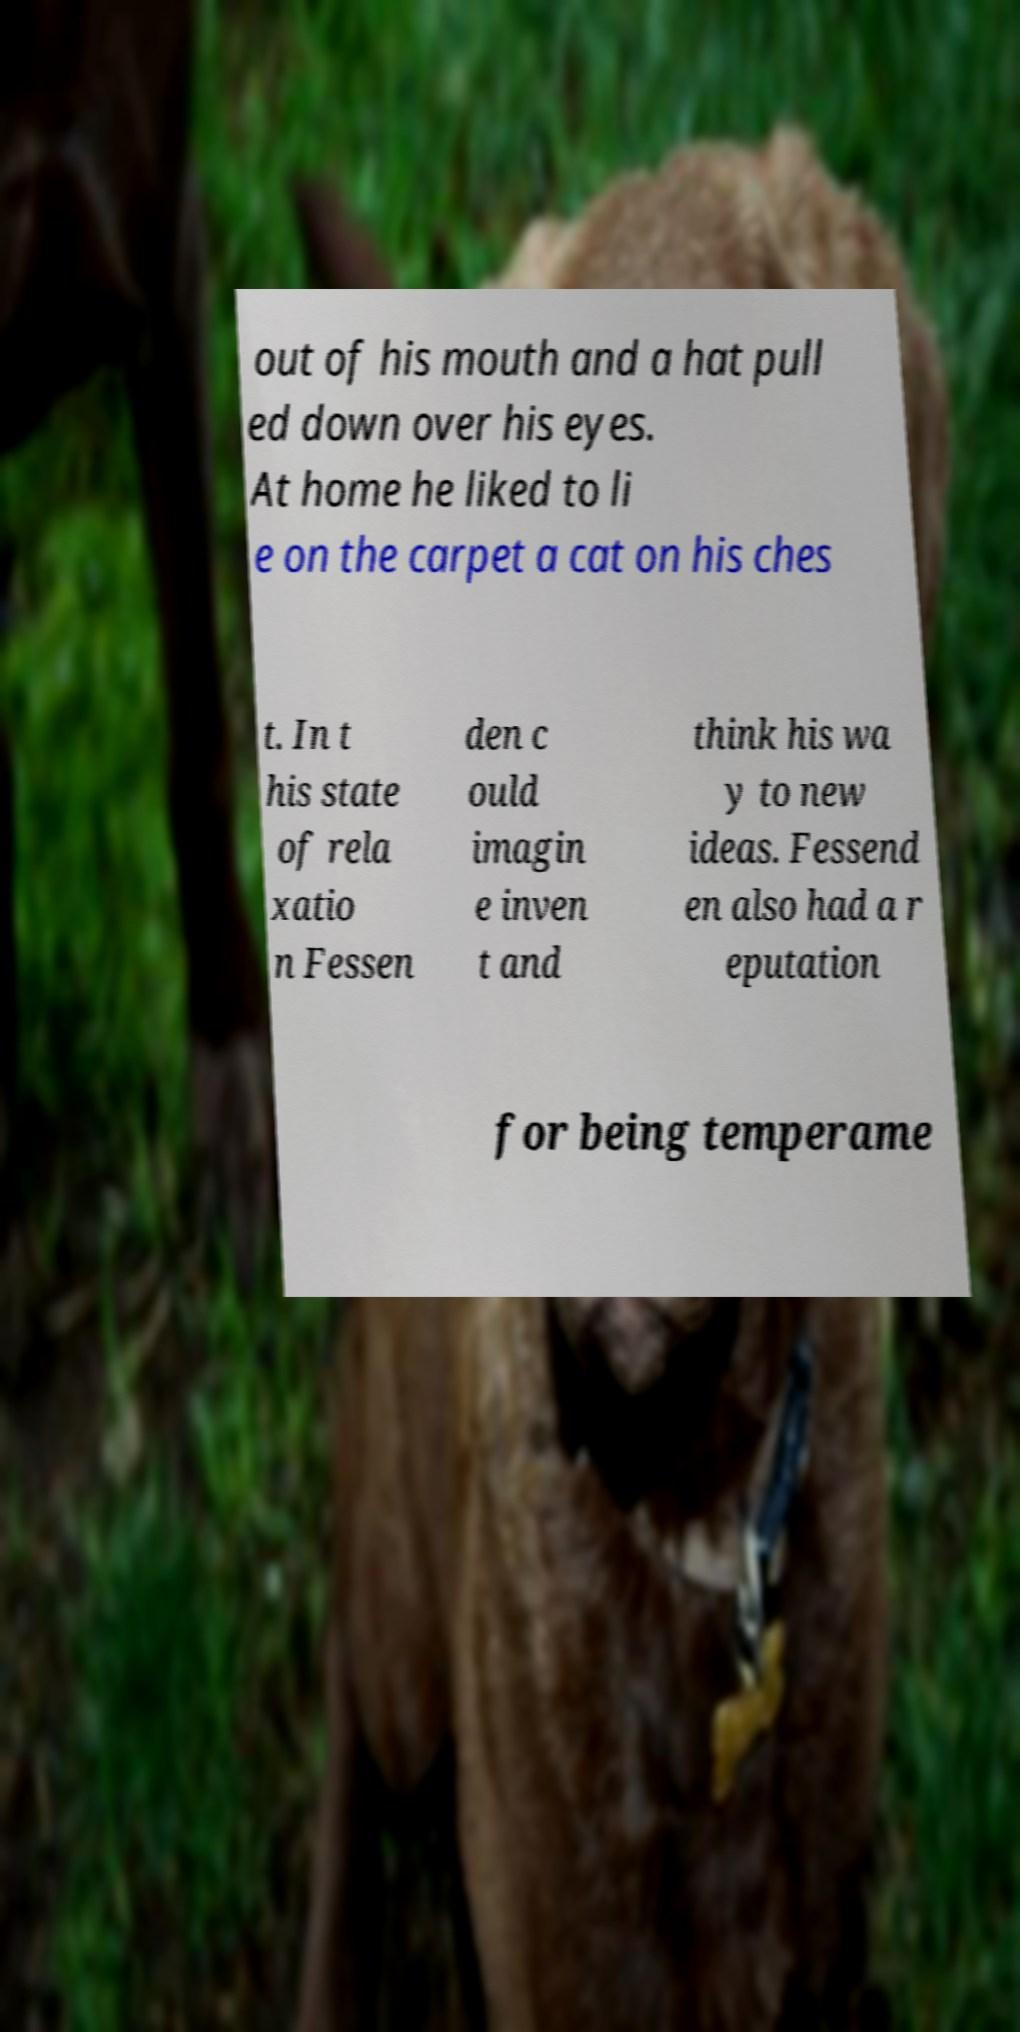I need the written content from this picture converted into text. Can you do that? out of his mouth and a hat pull ed down over his eyes. At home he liked to li e on the carpet a cat on his ches t. In t his state of rela xatio n Fessen den c ould imagin e inven t and think his wa y to new ideas. Fessend en also had a r eputation for being temperame 